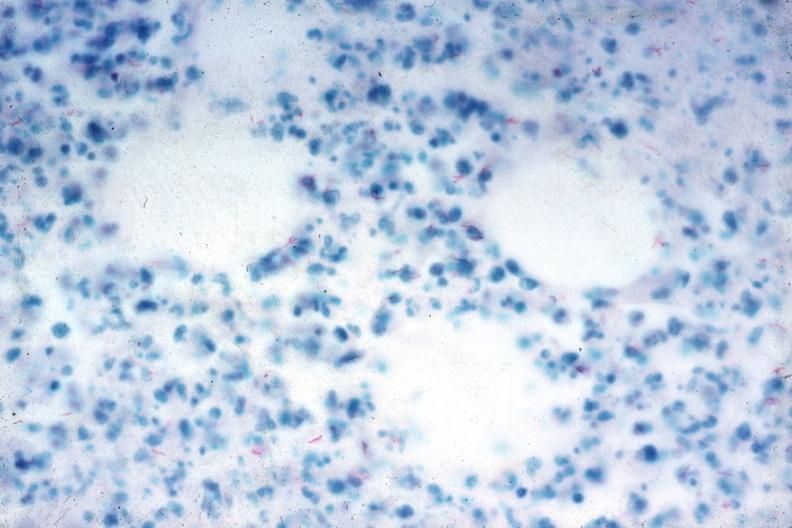does this image show acid fast stain numerous acid fast bacilli very good slide?
Answer the question using a single word or phrase. Yes 